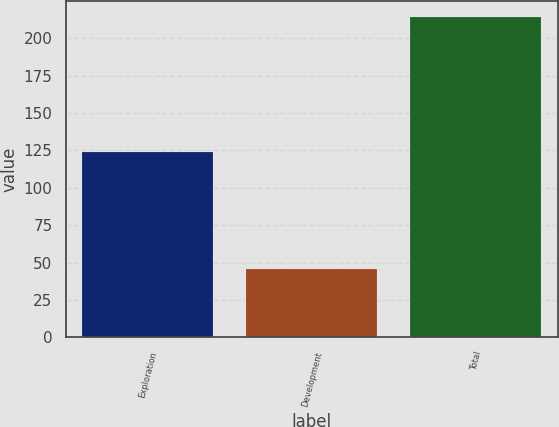Convert chart. <chart><loc_0><loc_0><loc_500><loc_500><bar_chart><fcel>Exploration<fcel>Development<fcel>Total<nl><fcel>124<fcel>46<fcel>214<nl></chart> 